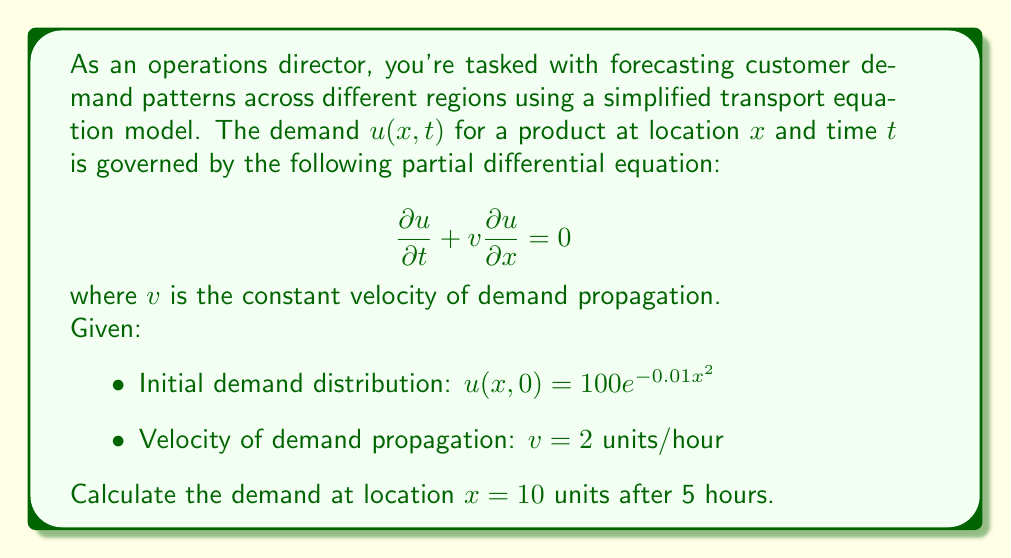Show me your answer to this math problem. To solve this problem, we'll use the method of characteristics for the transport equation.

1) The general solution to the transport equation $\frac{\partial u}{\partial t} + v \frac{\partial u}{\partial x} = 0$ is:

   $u(x,t) = f(x - vt)$

   where $f$ is determined by the initial condition.

2) From the initial condition, we know that:

   $u(x,0) = 100e^{-0.01x^2} = f(x)$

3) Therefore, the solution is:

   $u(x,t) = 100e^{-0.01(x-vt)^2}$

4) We're asked to find $u(10,5)$. Substituting these values and $v=2$:

   $u(10,5) = 100e^{-0.01(10-2\cdot5)^2}$

5) Simplify:
   $u(10,5) = 100e^{-0.01(10-10)^2} = 100e^{-0.01(0)^2} = 100e^0 = 100$

Therefore, the demand at location $x=10$ after 5 hours is 100 units.
Answer: 100 units 